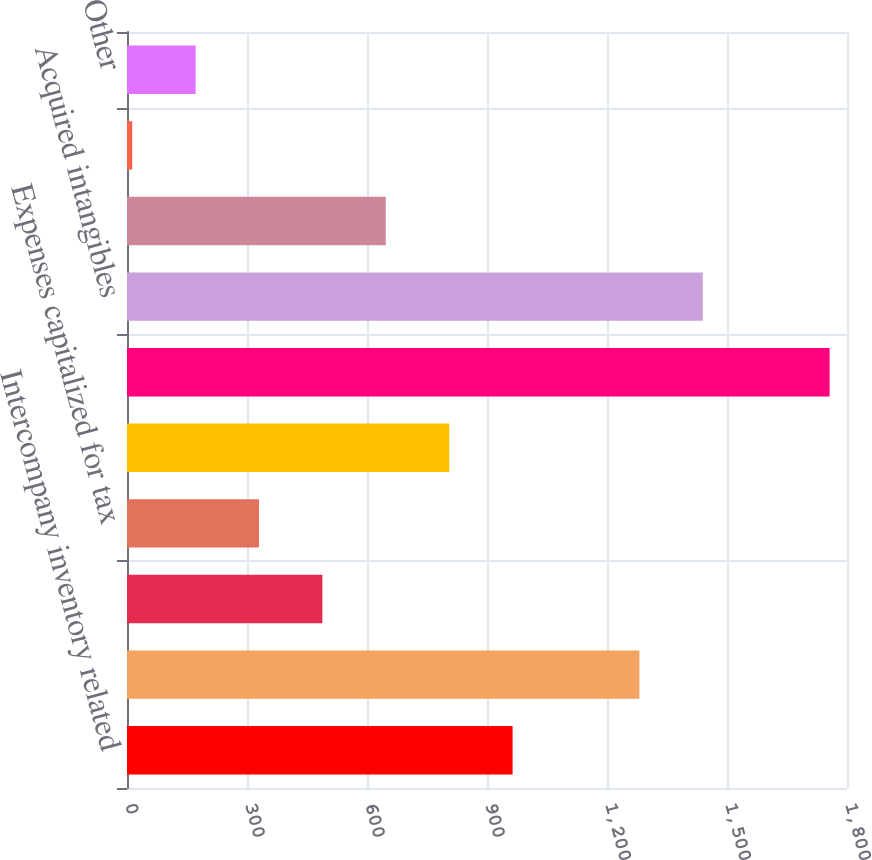<chart> <loc_0><loc_0><loc_500><loc_500><bar_chart><fcel>Intercompany inventory related<fcel>Expense accruals<fcel>Acquired net operating loss<fcel>Expenses capitalized for tax<fcel>Stock-based compensation<fcel>Net deferred tax assets<fcel>Acquired intangibles<fcel>Fixed assets<fcel>Unremitted foreign earnings<fcel>Other<nl><fcel>964<fcel>1281<fcel>488.5<fcel>330<fcel>805.5<fcel>1756.5<fcel>1439.5<fcel>647<fcel>13<fcel>171.5<nl></chart> 